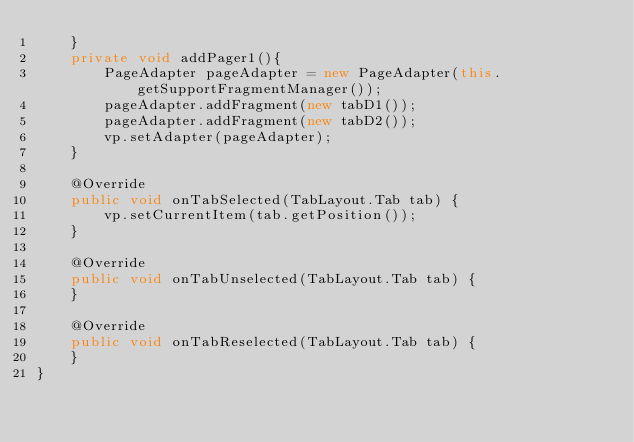Convert code to text. <code><loc_0><loc_0><loc_500><loc_500><_Java_>    }
    private void addPager1(){
        PageAdapter pageAdapter = new PageAdapter(this.getSupportFragmentManager());
        pageAdapter.addFragment(new tabD1());
        pageAdapter.addFragment(new tabD2());
        vp.setAdapter(pageAdapter);
    }

    @Override
    public void onTabSelected(TabLayout.Tab tab) {
        vp.setCurrentItem(tab.getPosition());
    }

    @Override
    public void onTabUnselected(TabLayout.Tab tab) {
    }

    @Override
    public void onTabReselected(TabLayout.Tab tab) {
    }
}
</code> 